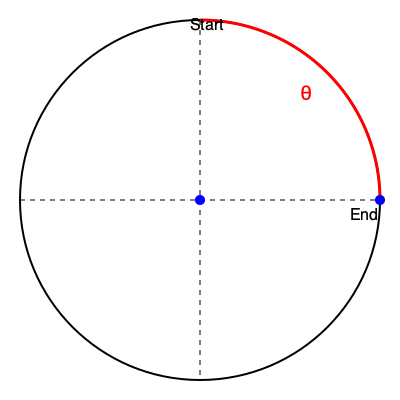A gymnast performs a giant swing on the high bar, completing a 90-degree rotation in 0.5 seconds. Assuming constant angular velocity, calculate the gymnast's rotation speed in revolutions per minute (rpm). To solve this problem, let's follow these steps:

1. Convert the given angle from degrees to radians:
   $$ \theta = 90° \times \frac{\pi}{180°} = \frac{\pi}{2} \text{ radians} $$

2. Calculate the angular velocity (ω) in radians per second:
   $$ \omega = \frac{\theta}{t} = \frac{\frac{\pi}{2}}{0.5} = \pi \text{ rad/s} $$

3. Convert angular velocity from radians per second to revolutions per minute:
   - First, find revolutions per second:
     $$ \text{rev/s} = \frac{\omega}{2\pi} = \frac{\pi}{2\pi} = \frac{1}{2} \text{ rev/s} $$
   - Then, convert to revolutions per minute:
     $$ \text{rpm} = \frac{1}{2} \text{ rev/s} \times 60 \text{ s/min} = 30 \text{ rpm} $$

Therefore, the gymnast's rotation speed is 30 rpm.
Answer: 30 rpm 